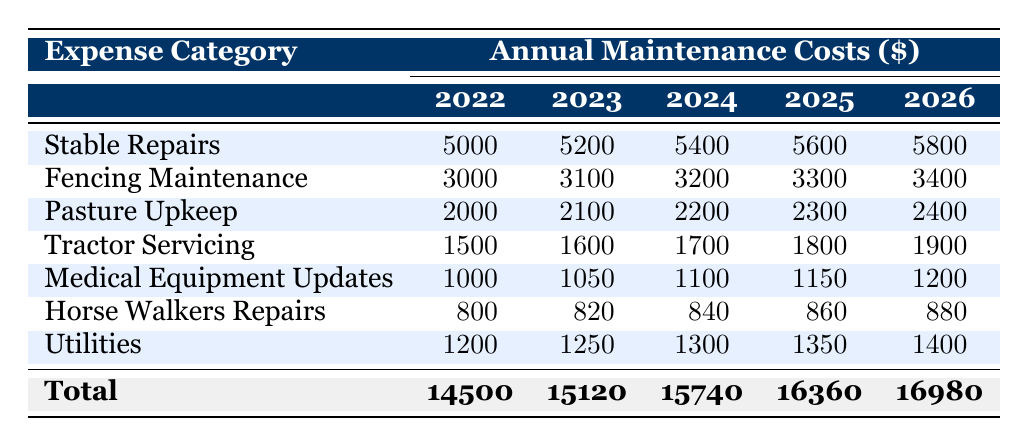What were the total maintenance costs in 2024? The total maintenance cost for 2024 is provided in the last row of the table under the "Total" column for that year, which is 15740 dollars.
Answer: 15740 Which expense category had the highest value in 2025? By reviewing the values for the year 2025 in each expense category, Stable Repairs has the highest value at 5600 dollars.
Answer: Stable Repairs Is there an increase in the Medical Equipment Updates cost from 2022 to 2026? The cost for Medical Equipment Updates in 2022 is 1000 dollars, and in 2026 it is 1200 dollars. Since 1200 is greater than 1000, there is indeed an increase.
Answer: Yes What is the average Pasture Upkeep cost over the years 2022 to 2026? To find the average, add the costs for Pasture Upkeep from 2022 to 2026: (2000 + 2100 + 2200 + 2300 + 2400) = 11000. Then divide by the number of years, which is 5: 11000 / 5 = 2200.
Answer: 2200 Did the Utilities expense increase every year from 2022 to 2026? Examining the Utilities expenses, in 2022 it is 1200, then increases to 1250 in 2023, and continues to rise each subsequent year, ending at 1400 in 2026. Since every value is greater than the previous one, the answer is yes.
Answer: Yes What is the total increase in Stable Repairs costs from 2022 to 2026? The Stable Repairs cost in 2022 is 5000 dollars, and in 2026, it is 5800 dollars. The increase can be calculated as: 5800 - 5000 = 800 dollars.
Answer: 800 Which two expense categories have the same annual increase from 2022 to 2026? By examining the yearly increases, Fencing Maintenance increases by 400 dollars each year, and Pasture Upkeep also increases by 400 dollars each year. Thus, these two categories have the same annual increase.
Answer: Fencing Maintenance and Pasture Upkeep What were the total maintenance costs for 2023? The total maintenance cost for 2023 can be found in the last row under the "Total" column, which is 15120 dollars.
Answer: 15120 